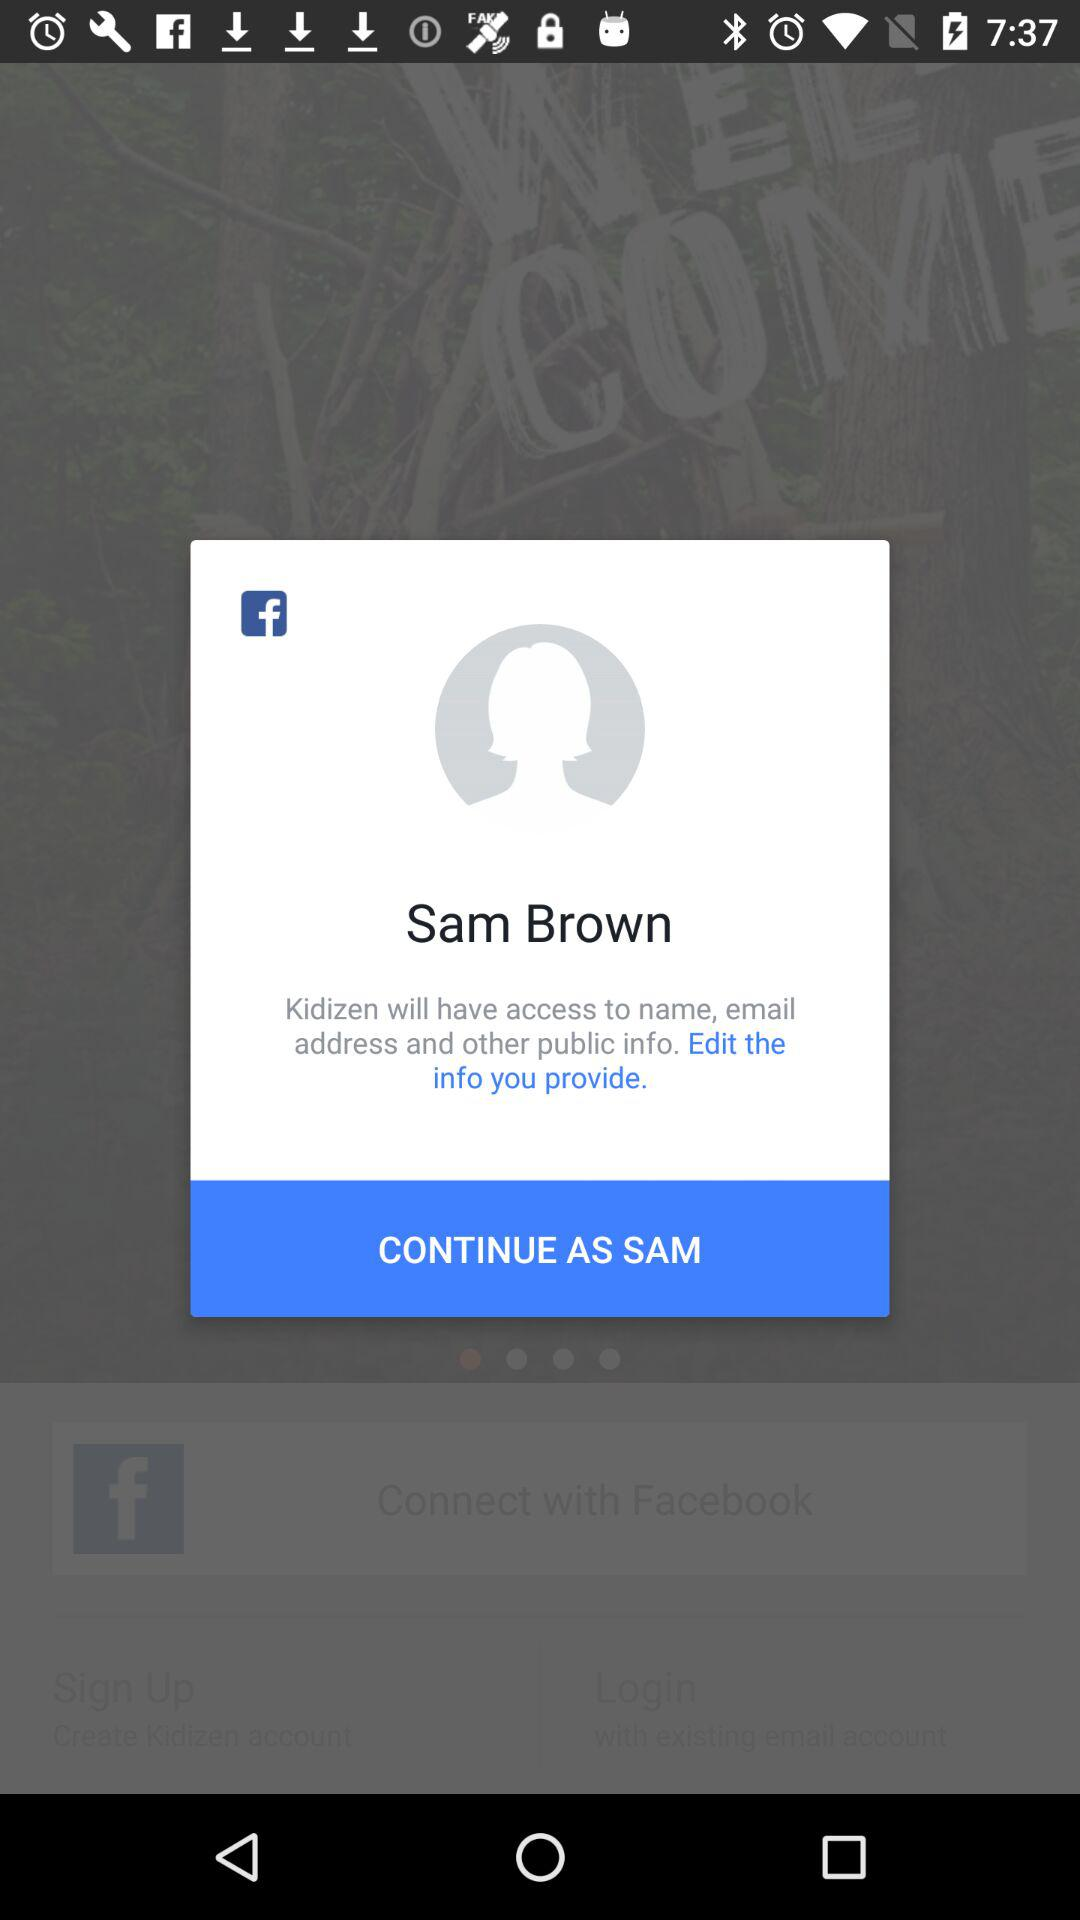What application is asking for permission? The application that is asking for permission is "Kidizen". 